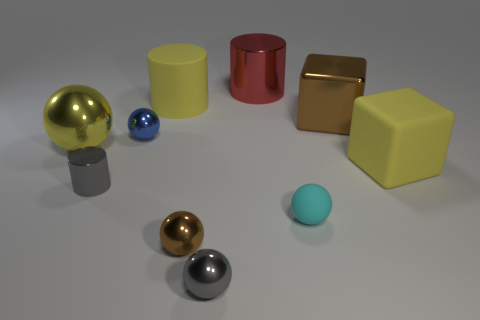Subtract 1 cylinders. How many cylinders are left? 2 Subtract all cyan matte spheres. How many spheres are left? 4 Subtract all yellow balls. How many balls are left? 4 Subtract all purple spheres. Subtract all red cylinders. How many spheres are left? 5 Subtract all cylinders. How many objects are left? 7 Add 10 small gray rubber objects. How many small gray rubber objects exist? 10 Subtract 0 cyan cylinders. How many objects are left? 10 Subtract all large yellow cylinders. Subtract all tiny shiny cylinders. How many objects are left? 8 Add 5 small blue things. How many small blue things are left? 6 